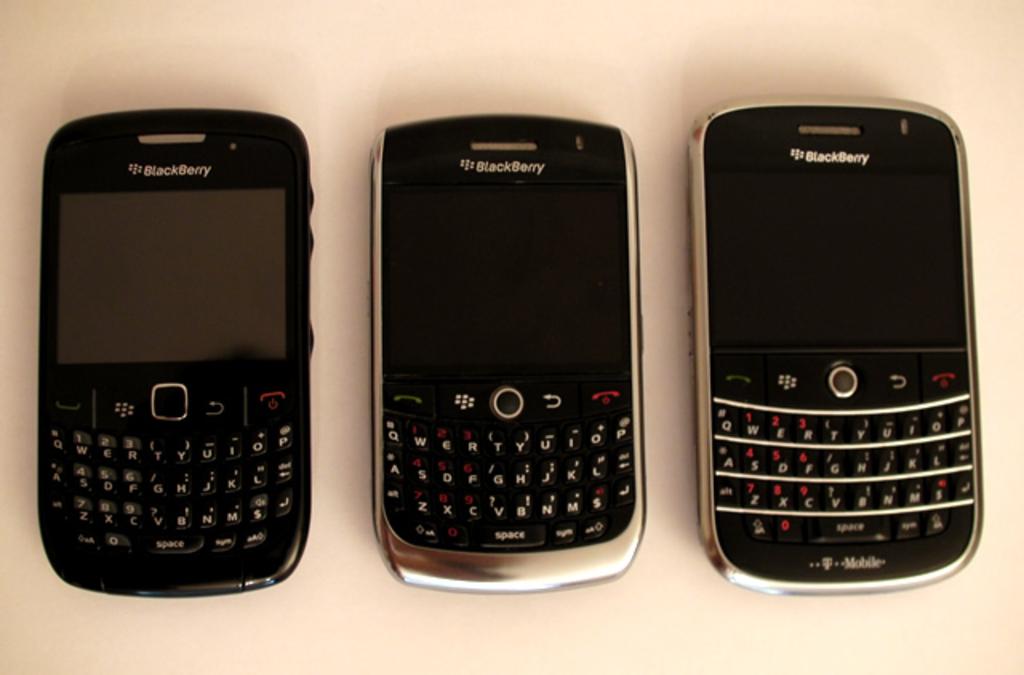What style of phones are these?
Provide a succinct answer. Blackberry. Who is the service provider of a phone?
Make the answer very short. T mobile. 